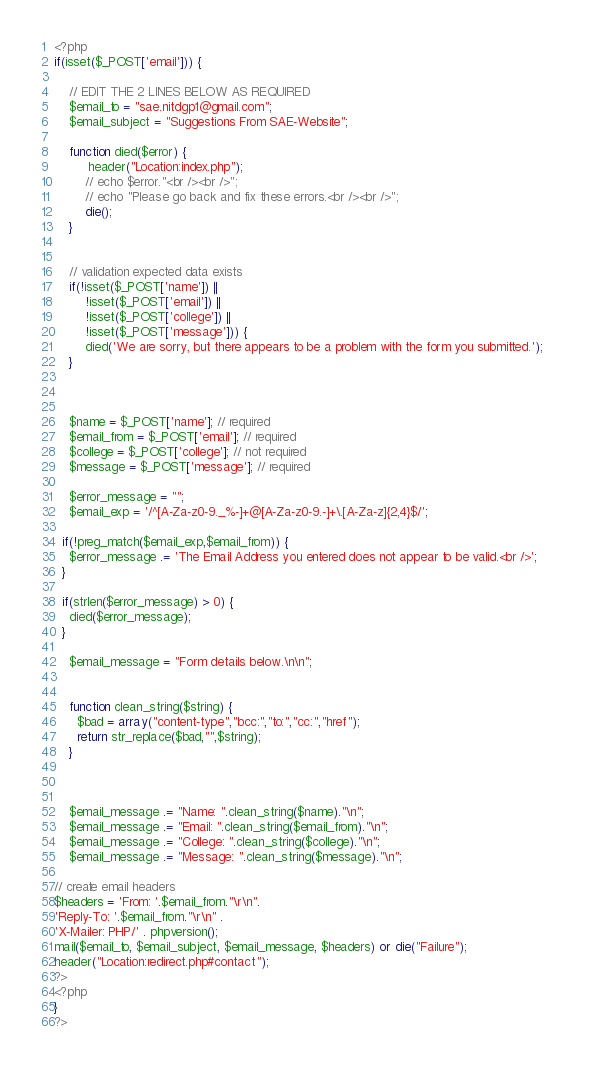Convert code to text. <code><loc_0><loc_0><loc_500><loc_500><_PHP_><?php
if(isset($_POST['email'])) {
 
    // EDIT THE 2 LINES BELOW AS REQUIRED
    $email_to = "sae.nitdgp1@gmail.com";
    $email_subject = "Suggestions From SAE-Website";
 
    function died($error) {
         header("Location:index.php");
        // echo $error."<br /><br />";
        // echo "Please go back and fix these errors.<br /><br />";
        die();
    }
 
 
    // validation expected data exists
    if(!isset($_POST['name']) ||
        !isset($_POST['email']) ||
        !isset($_POST['college']) ||
        !isset($_POST['message'])) {
        died('We are sorry, but there appears to be a problem with the form you submitted.');       
    }
 
     
 
    $name = $_POST['name']; // required
    $email_from = $_POST['email']; // required
    $college = $_POST['college']; // not required
    $message = $_POST['message']; // required
 
    $error_message = "";
    $email_exp = '/^[A-Za-z0-9._%-]+@[A-Za-z0-9.-]+\.[A-Za-z]{2,4}$/';
 
  if(!preg_match($email_exp,$email_from)) {
    $error_message .= 'The Email Address you entered does not appear to be valid.<br />';
  }
 
  if(strlen($error_message) > 0) {
    died($error_message);
  }
 
    $email_message = "Form details below.\n\n";
 
     
    function clean_string($string) {
      $bad = array("content-type","bcc:","to:","cc:","href");
      return str_replace($bad,"",$string);
    }
 
     
 
    $email_message .= "Name: ".clean_string($name)."\n";
    $email_message .= "Email: ".clean_string($email_from)."\n";
    $email_message .= "College: ".clean_string($college)."\n";
    $email_message .= "Message: ".clean_string($message)."\n";
 
// create email headers
$headers = 'From: '.$email_from."\r\n".
'Reply-To: '.$email_from."\r\n" .
'X-Mailer: PHP/' . phpversion();
mail($email_to, $email_subject, $email_message, $headers) or die("Failure");
header("Location:redirect.php#contact");
?>
<?php
}
?></code> 